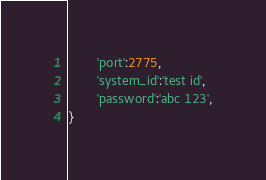Convert code to text. <code><loc_0><loc_0><loc_500><loc_500><_Python_>        'port':2775,
        'system_id':'test id',
        'password':'abc 123',
}
</code> 